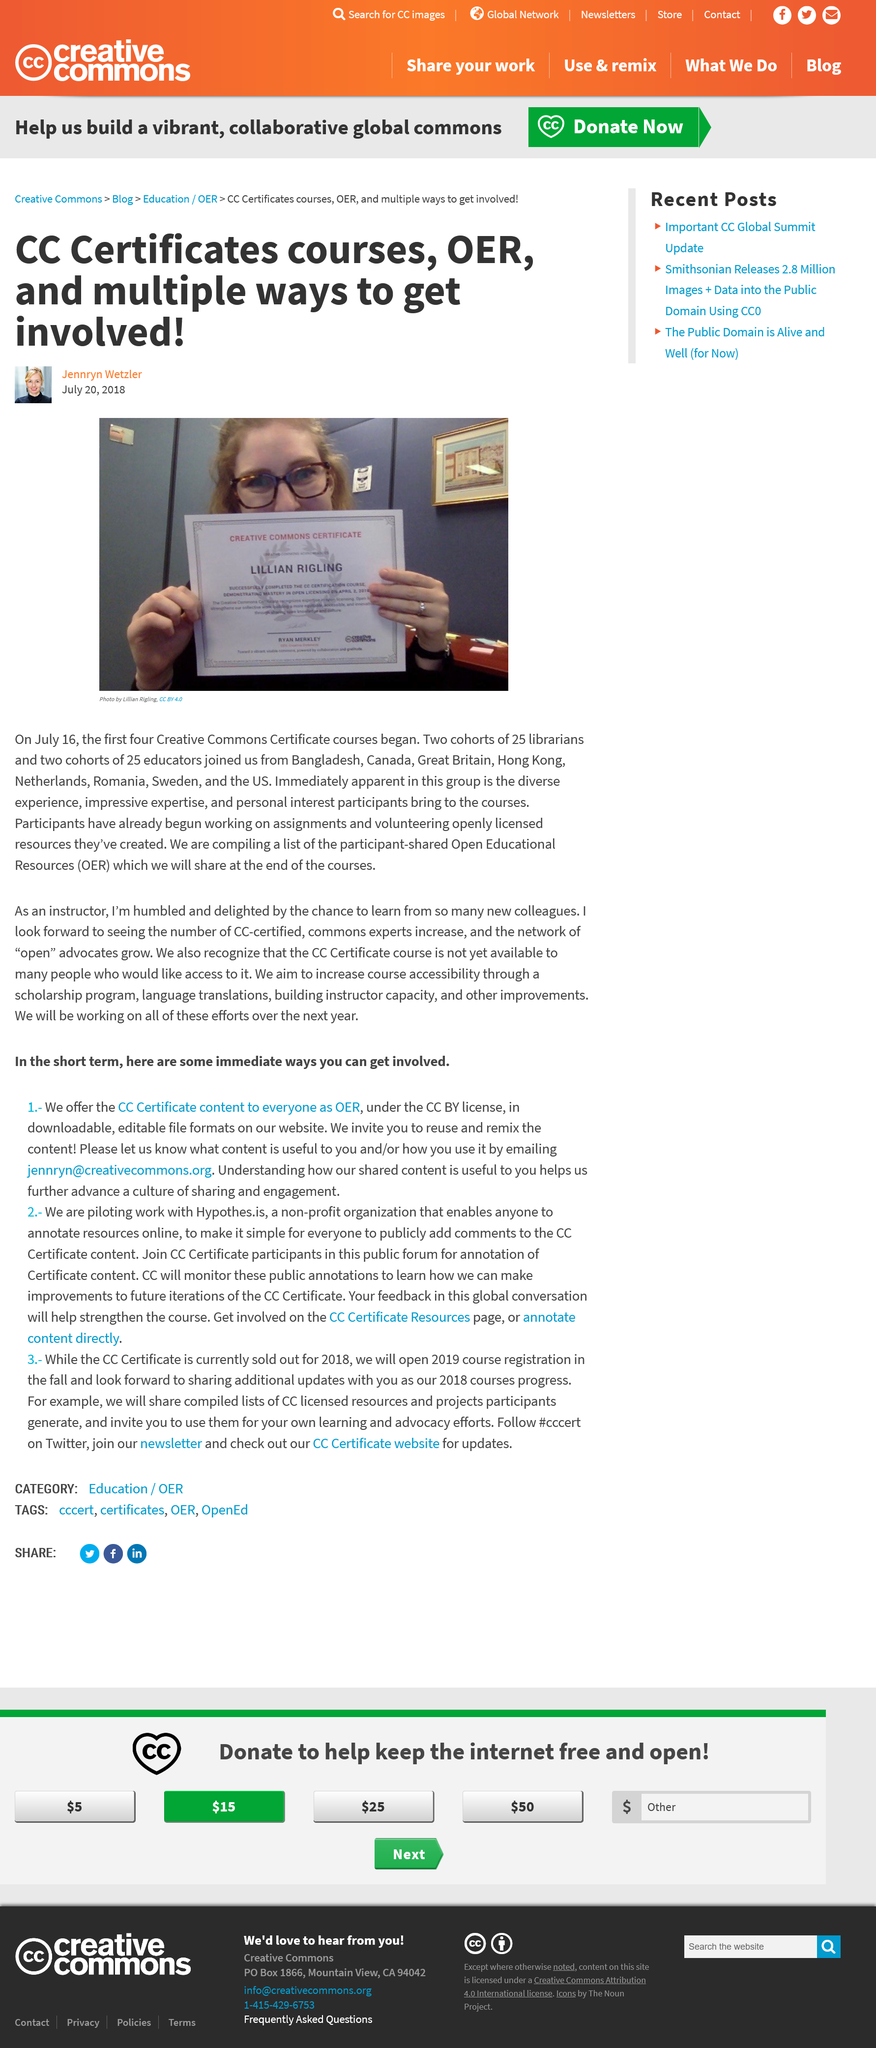Point out several critical features in this image. Open Educational Resources, commonly referred to as OER, refers to a collection of educational materials that are made freely available for anyone to use, modify, and distribute. These materials can include textbooks, videos, audio files, and other multimedia resources, and are typically licensed under open copyright licenses that allow for reuse and remixing. OER are used by educators and learners around the world to support teaching and learning in a variety of contexts, and are a key part of the growing movement towards openness and accessibility in education. The first four Creative Commons Certificate courses began on July 16th, 2018. Lillian Rigling is depicted in the primary visual representation. 